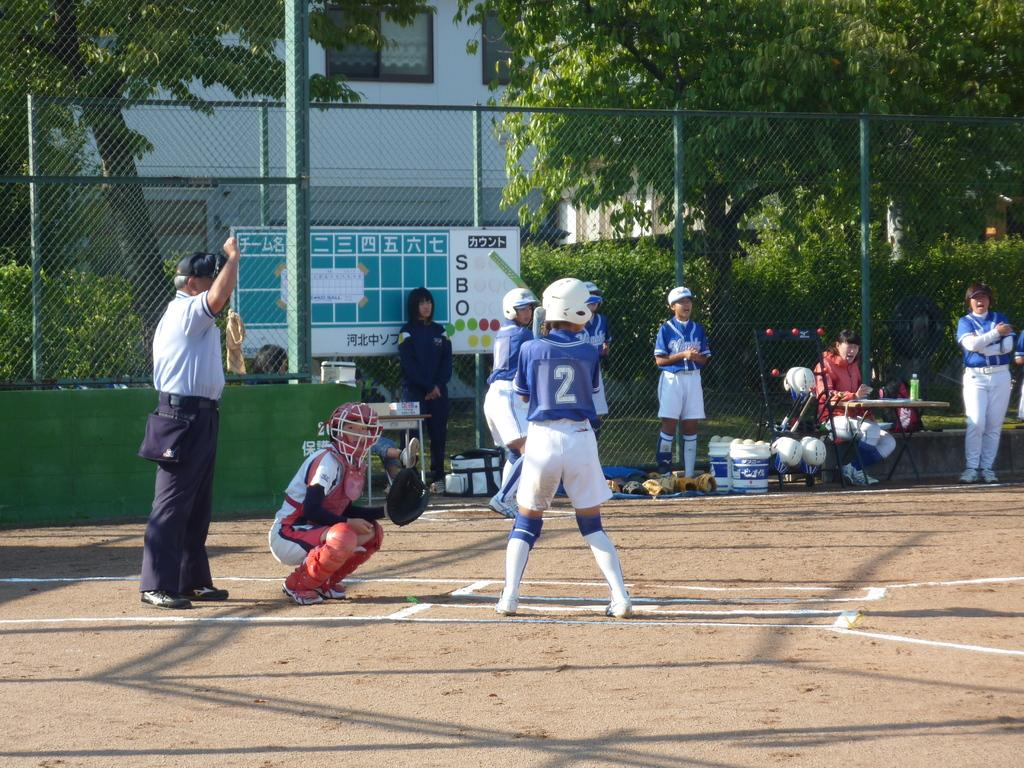<image>
Give a short and clear explanation of the subsequent image. Baseball game in front of scoreboard with Korean writing and number 2 is at bat 